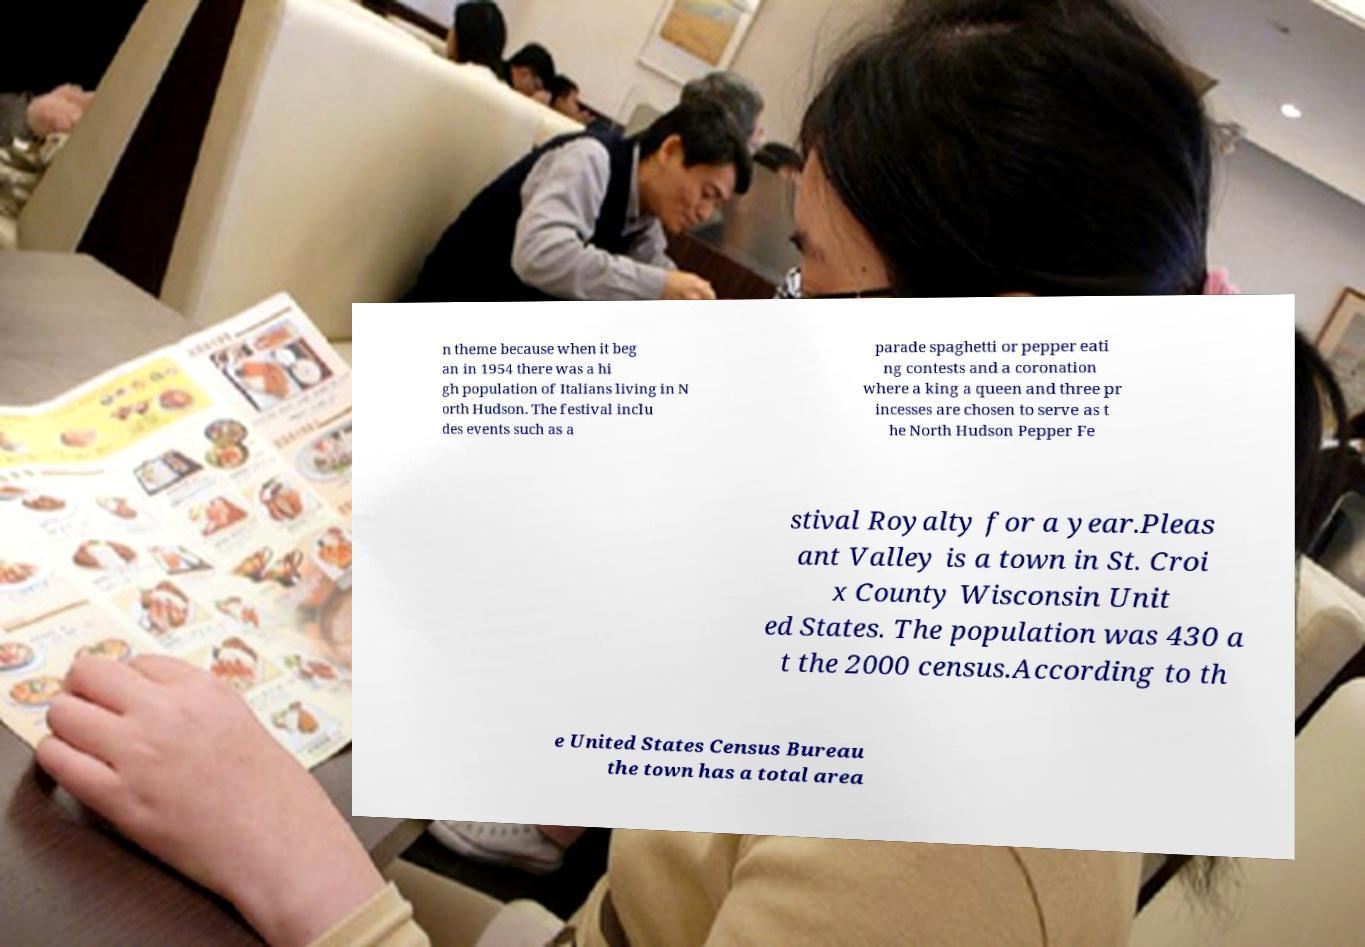Please identify and transcribe the text found in this image. n theme because when it beg an in 1954 there was a hi gh population of Italians living in N orth Hudson. The festival inclu des events such as a parade spaghetti or pepper eati ng contests and a coronation where a king a queen and three pr incesses are chosen to serve as t he North Hudson Pepper Fe stival Royalty for a year.Pleas ant Valley is a town in St. Croi x County Wisconsin Unit ed States. The population was 430 a t the 2000 census.According to th e United States Census Bureau the town has a total area 